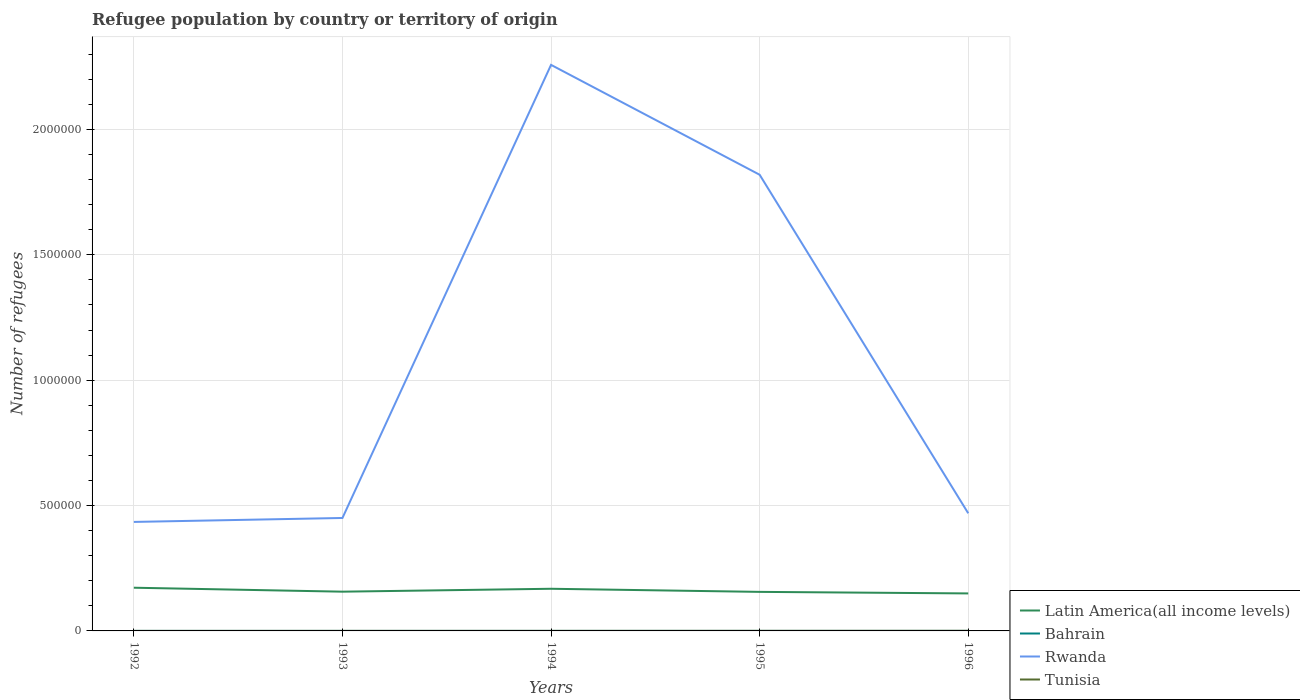Is the number of lines equal to the number of legend labels?
Provide a succinct answer. Yes. Across all years, what is the maximum number of refugees in Bahrain?
Your response must be concise. 53. What is the total number of refugees in Latin America(all income levels) in the graph?
Keep it short and to the point. 6175. What is the difference between the highest and the second highest number of refugees in Tunisia?
Make the answer very short. 320. Is the number of refugees in Latin America(all income levels) strictly greater than the number of refugees in Bahrain over the years?
Provide a succinct answer. No. How many lines are there?
Give a very brief answer. 4. How many years are there in the graph?
Offer a terse response. 5. Where does the legend appear in the graph?
Offer a terse response. Bottom right. How many legend labels are there?
Your answer should be compact. 4. What is the title of the graph?
Make the answer very short. Refugee population by country or territory of origin. What is the label or title of the Y-axis?
Your answer should be very brief. Number of refugees. What is the Number of refugees of Latin America(all income levels) in 1992?
Your response must be concise. 1.72e+05. What is the Number of refugees of Rwanda in 1992?
Your answer should be very brief. 4.35e+05. What is the Number of refugees of Latin America(all income levels) in 1993?
Give a very brief answer. 1.57e+05. What is the Number of refugees of Rwanda in 1993?
Keep it short and to the point. 4.50e+05. What is the Number of refugees in Tunisia in 1993?
Offer a terse response. 104. What is the Number of refugees of Latin America(all income levels) in 1994?
Offer a terse response. 1.68e+05. What is the Number of refugees of Bahrain in 1994?
Keep it short and to the point. 75. What is the Number of refugees of Rwanda in 1994?
Offer a very short reply. 2.26e+06. What is the Number of refugees of Tunisia in 1994?
Provide a short and direct response. 212. What is the Number of refugees of Latin America(all income levels) in 1995?
Give a very brief answer. 1.56e+05. What is the Number of refugees in Rwanda in 1995?
Keep it short and to the point. 1.82e+06. What is the Number of refugees in Tunisia in 1995?
Offer a very short reply. 333. What is the Number of refugees of Latin America(all income levels) in 1996?
Provide a succinct answer. 1.50e+05. What is the Number of refugees in Bahrain in 1996?
Give a very brief answer. 63. What is the Number of refugees in Rwanda in 1996?
Your response must be concise. 4.69e+05. What is the Number of refugees of Tunisia in 1996?
Your answer should be compact. 406. Across all years, what is the maximum Number of refugees in Latin America(all income levels)?
Ensure brevity in your answer.  1.72e+05. Across all years, what is the maximum Number of refugees in Rwanda?
Your answer should be very brief. 2.26e+06. Across all years, what is the maximum Number of refugees of Tunisia?
Offer a very short reply. 406. Across all years, what is the minimum Number of refugees in Latin America(all income levels)?
Offer a very short reply. 1.50e+05. Across all years, what is the minimum Number of refugees of Bahrain?
Make the answer very short. 53. Across all years, what is the minimum Number of refugees of Rwanda?
Make the answer very short. 4.35e+05. What is the total Number of refugees in Latin America(all income levels) in the graph?
Keep it short and to the point. 8.02e+05. What is the total Number of refugees of Bahrain in the graph?
Your answer should be very brief. 322. What is the total Number of refugees in Rwanda in the graph?
Offer a very short reply. 5.43e+06. What is the total Number of refugees in Tunisia in the graph?
Give a very brief answer. 1141. What is the difference between the Number of refugees in Latin America(all income levels) in 1992 and that in 1993?
Offer a terse response. 1.58e+04. What is the difference between the Number of refugees of Rwanda in 1992 and that in 1993?
Offer a terse response. -1.57e+04. What is the difference between the Number of refugees in Tunisia in 1992 and that in 1993?
Give a very brief answer. -18. What is the difference between the Number of refugees of Latin America(all income levels) in 1992 and that in 1994?
Offer a very short reply. 4203. What is the difference between the Number of refugees in Rwanda in 1992 and that in 1994?
Ensure brevity in your answer.  -1.82e+06. What is the difference between the Number of refugees of Tunisia in 1992 and that in 1994?
Your answer should be very brief. -126. What is the difference between the Number of refugees of Latin America(all income levels) in 1992 and that in 1995?
Your answer should be compact. 1.66e+04. What is the difference between the Number of refugees in Bahrain in 1992 and that in 1995?
Provide a succinct answer. -18. What is the difference between the Number of refugees in Rwanda in 1992 and that in 1995?
Offer a very short reply. -1.38e+06. What is the difference between the Number of refugees in Tunisia in 1992 and that in 1995?
Offer a terse response. -247. What is the difference between the Number of refugees in Latin America(all income levels) in 1992 and that in 1996?
Your answer should be compact. 2.28e+04. What is the difference between the Number of refugees of Bahrain in 1992 and that in 1996?
Your response must be concise. -10. What is the difference between the Number of refugees in Rwanda in 1992 and that in 1996?
Ensure brevity in your answer.  -3.44e+04. What is the difference between the Number of refugees of Tunisia in 1992 and that in 1996?
Your response must be concise. -320. What is the difference between the Number of refugees in Latin America(all income levels) in 1993 and that in 1994?
Your answer should be compact. -1.16e+04. What is the difference between the Number of refugees in Rwanda in 1993 and that in 1994?
Offer a terse response. -1.81e+06. What is the difference between the Number of refugees in Tunisia in 1993 and that in 1994?
Offer a terse response. -108. What is the difference between the Number of refugees in Latin America(all income levels) in 1993 and that in 1995?
Offer a terse response. 825. What is the difference between the Number of refugees in Bahrain in 1993 and that in 1995?
Provide a succinct answer. -11. What is the difference between the Number of refugees of Rwanda in 1993 and that in 1995?
Keep it short and to the point. -1.37e+06. What is the difference between the Number of refugees in Tunisia in 1993 and that in 1995?
Give a very brief answer. -229. What is the difference between the Number of refugees of Latin America(all income levels) in 1993 and that in 1996?
Ensure brevity in your answer.  7000. What is the difference between the Number of refugees in Bahrain in 1993 and that in 1996?
Make the answer very short. -3. What is the difference between the Number of refugees in Rwanda in 1993 and that in 1996?
Your answer should be compact. -1.87e+04. What is the difference between the Number of refugees of Tunisia in 1993 and that in 1996?
Your response must be concise. -302. What is the difference between the Number of refugees in Latin America(all income levels) in 1994 and that in 1995?
Provide a short and direct response. 1.24e+04. What is the difference between the Number of refugees of Bahrain in 1994 and that in 1995?
Give a very brief answer. 4. What is the difference between the Number of refugees in Rwanda in 1994 and that in 1995?
Your answer should be compact. 4.38e+05. What is the difference between the Number of refugees of Tunisia in 1994 and that in 1995?
Make the answer very short. -121. What is the difference between the Number of refugees in Latin America(all income levels) in 1994 and that in 1996?
Make the answer very short. 1.86e+04. What is the difference between the Number of refugees in Bahrain in 1994 and that in 1996?
Provide a short and direct response. 12. What is the difference between the Number of refugees in Rwanda in 1994 and that in 1996?
Make the answer very short. 1.79e+06. What is the difference between the Number of refugees of Tunisia in 1994 and that in 1996?
Provide a succinct answer. -194. What is the difference between the Number of refugees of Latin America(all income levels) in 1995 and that in 1996?
Your answer should be compact. 6175. What is the difference between the Number of refugees of Rwanda in 1995 and that in 1996?
Offer a terse response. 1.35e+06. What is the difference between the Number of refugees of Tunisia in 1995 and that in 1996?
Ensure brevity in your answer.  -73. What is the difference between the Number of refugees of Latin America(all income levels) in 1992 and the Number of refugees of Bahrain in 1993?
Offer a very short reply. 1.72e+05. What is the difference between the Number of refugees in Latin America(all income levels) in 1992 and the Number of refugees in Rwanda in 1993?
Keep it short and to the point. -2.78e+05. What is the difference between the Number of refugees of Latin America(all income levels) in 1992 and the Number of refugees of Tunisia in 1993?
Your response must be concise. 1.72e+05. What is the difference between the Number of refugees of Bahrain in 1992 and the Number of refugees of Rwanda in 1993?
Your answer should be very brief. -4.50e+05. What is the difference between the Number of refugees of Bahrain in 1992 and the Number of refugees of Tunisia in 1993?
Your answer should be compact. -51. What is the difference between the Number of refugees of Rwanda in 1992 and the Number of refugees of Tunisia in 1993?
Keep it short and to the point. 4.35e+05. What is the difference between the Number of refugees of Latin America(all income levels) in 1992 and the Number of refugees of Bahrain in 1994?
Your answer should be compact. 1.72e+05. What is the difference between the Number of refugees of Latin America(all income levels) in 1992 and the Number of refugees of Rwanda in 1994?
Give a very brief answer. -2.09e+06. What is the difference between the Number of refugees of Latin America(all income levels) in 1992 and the Number of refugees of Tunisia in 1994?
Your response must be concise. 1.72e+05. What is the difference between the Number of refugees in Bahrain in 1992 and the Number of refugees in Rwanda in 1994?
Your answer should be very brief. -2.26e+06. What is the difference between the Number of refugees of Bahrain in 1992 and the Number of refugees of Tunisia in 1994?
Keep it short and to the point. -159. What is the difference between the Number of refugees in Rwanda in 1992 and the Number of refugees in Tunisia in 1994?
Your response must be concise. 4.35e+05. What is the difference between the Number of refugees of Latin America(all income levels) in 1992 and the Number of refugees of Bahrain in 1995?
Your answer should be compact. 1.72e+05. What is the difference between the Number of refugees of Latin America(all income levels) in 1992 and the Number of refugees of Rwanda in 1995?
Give a very brief answer. -1.65e+06. What is the difference between the Number of refugees of Latin America(all income levels) in 1992 and the Number of refugees of Tunisia in 1995?
Ensure brevity in your answer.  1.72e+05. What is the difference between the Number of refugees of Bahrain in 1992 and the Number of refugees of Rwanda in 1995?
Your answer should be very brief. -1.82e+06. What is the difference between the Number of refugees of Bahrain in 1992 and the Number of refugees of Tunisia in 1995?
Give a very brief answer. -280. What is the difference between the Number of refugees of Rwanda in 1992 and the Number of refugees of Tunisia in 1995?
Keep it short and to the point. 4.34e+05. What is the difference between the Number of refugees of Latin America(all income levels) in 1992 and the Number of refugees of Bahrain in 1996?
Offer a terse response. 1.72e+05. What is the difference between the Number of refugees of Latin America(all income levels) in 1992 and the Number of refugees of Rwanda in 1996?
Provide a succinct answer. -2.97e+05. What is the difference between the Number of refugees in Latin America(all income levels) in 1992 and the Number of refugees in Tunisia in 1996?
Make the answer very short. 1.72e+05. What is the difference between the Number of refugees in Bahrain in 1992 and the Number of refugees in Rwanda in 1996?
Your response must be concise. -4.69e+05. What is the difference between the Number of refugees in Bahrain in 1992 and the Number of refugees in Tunisia in 1996?
Make the answer very short. -353. What is the difference between the Number of refugees of Rwanda in 1992 and the Number of refugees of Tunisia in 1996?
Your answer should be compact. 4.34e+05. What is the difference between the Number of refugees in Latin America(all income levels) in 1993 and the Number of refugees in Bahrain in 1994?
Keep it short and to the point. 1.56e+05. What is the difference between the Number of refugees in Latin America(all income levels) in 1993 and the Number of refugees in Rwanda in 1994?
Give a very brief answer. -2.10e+06. What is the difference between the Number of refugees in Latin America(all income levels) in 1993 and the Number of refugees in Tunisia in 1994?
Provide a succinct answer. 1.56e+05. What is the difference between the Number of refugees of Bahrain in 1993 and the Number of refugees of Rwanda in 1994?
Ensure brevity in your answer.  -2.26e+06. What is the difference between the Number of refugees in Bahrain in 1993 and the Number of refugees in Tunisia in 1994?
Keep it short and to the point. -152. What is the difference between the Number of refugees in Rwanda in 1993 and the Number of refugees in Tunisia in 1994?
Offer a terse response. 4.50e+05. What is the difference between the Number of refugees of Latin America(all income levels) in 1993 and the Number of refugees of Bahrain in 1995?
Provide a succinct answer. 1.56e+05. What is the difference between the Number of refugees of Latin America(all income levels) in 1993 and the Number of refugees of Rwanda in 1995?
Your answer should be compact. -1.66e+06. What is the difference between the Number of refugees of Latin America(all income levels) in 1993 and the Number of refugees of Tunisia in 1995?
Provide a short and direct response. 1.56e+05. What is the difference between the Number of refugees in Bahrain in 1993 and the Number of refugees in Rwanda in 1995?
Provide a succinct answer. -1.82e+06. What is the difference between the Number of refugees of Bahrain in 1993 and the Number of refugees of Tunisia in 1995?
Make the answer very short. -273. What is the difference between the Number of refugees of Rwanda in 1993 and the Number of refugees of Tunisia in 1995?
Your response must be concise. 4.50e+05. What is the difference between the Number of refugees of Latin America(all income levels) in 1993 and the Number of refugees of Bahrain in 1996?
Make the answer very short. 1.56e+05. What is the difference between the Number of refugees in Latin America(all income levels) in 1993 and the Number of refugees in Rwanda in 1996?
Provide a short and direct response. -3.13e+05. What is the difference between the Number of refugees in Latin America(all income levels) in 1993 and the Number of refugees in Tunisia in 1996?
Ensure brevity in your answer.  1.56e+05. What is the difference between the Number of refugees in Bahrain in 1993 and the Number of refugees in Rwanda in 1996?
Give a very brief answer. -4.69e+05. What is the difference between the Number of refugees of Bahrain in 1993 and the Number of refugees of Tunisia in 1996?
Provide a short and direct response. -346. What is the difference between the Number of refugees of Rwanda in 1993 and the Number of refugees of Tunisia in 1996?
Make the answer very short. 4.50e+05. What is the difference between the Number of refugees of Latin America(all income levels) in 1994 and the Number of refugees of Bahrain in 1995?
Provide a succinct answer. 1.68e+05. What is the difference between the Number of refugees in Latin America(all income levels) in 1994 and the Number of refugees in Rwanda in 1995?
Your response must be concise. -1.65e+06. What is the difference between the Number of refugees of Latin America(all income levels) in 1994 and the Number of refugees of Tunisia in 1995?
Provide a short and direct response. 1.68e+05. What is the difference between the Number of refugees of Bahrain in 1994 and the Number of refugees of Rwanda in 1995?
Give a very brief answer. -1.82e+06. What is the difference between the Number of refugees of Bahrain in 1994 and the Number of refugees of Tunisia in 1995?
Keep it short and to the point. -258. What is the difference between the Number of refugees in Rwanda in 1994 and the Number of refugees in Tunisia in 1995?
Provide a succinct answer. 2.26e+06. What is the difference between the Number of refugees of Latin America(all income levels) in 1994 and the Number of refugees of Bahrain in 1996?
Keep it short and to the point. 1.68e+05. What is the difference between the Number of refugees in Latin America(all income levels) in 1994 and the Number of refugees in Rwanda in 1996?
Keep it short and to the point. -3.01e+05. What is the difference between the Number of refugees in Latin America(all income levels) in 1994 and the Number of refugees in Tunisia in 1996?
Provide a short and direct response. 1.68e+05. What is the difference between the Number of refugees in Bahrain in 1994 and the Number of refugees in Rwanda in 1996?
Give a very brief answer. -4.69e+05. What is the difference between the Number of refugees of Bahrain in 1994 and the Number of refugees of Tunisia in 1996?
Provide a short and direct response. -331. What is the difference between the Number of refugees in Rwanda in 1994 and the Number of refugees in Tunisia in 1996?
Keep it short and to the point. 2.26e+06. What is the difference between the Number of refugees in Latin America(all income levels) in 1995 and the Number of refugees in Bahrain in 1996?
Give a very brief answer. 1.56e+05. What is the difference between the Number of refugees of Latin America(all income levels) in 1995 and the Number of refugees of Rwanda in 1996?
Your answer should be very brief. -3.13e+05. What is the difference between the Number of refugees in Latin America(all income levels) in 1995 and the Number of refugees in Tunisia in 1996?
Make the answer very short. 1.55e+05. What is the difference between the Number of refugees in Bahrain in 1995 and the Number of refugees in Rwanda in 1996?
Offer a very short reply. -4.69e+05. What is the difference between the Number of refugees in Bahrain in 1995 and the Number of refugees in Tunisia in 1996?
Your response must be concise. -335. What is the difference between the Number of refugees of Rwanda in 1995 and the Number of refugees of Tunisia in 1996?
Make the answer very short. 1.82e+06. What is the average Number of refugees in Latin America(all income levels) per year?
Give a very brief answer. 1.60e+05. What is the average Number of refugees in Bahrain per year?
Your response must be concise. 64.4. What is the average Number of refugees in Rwanda per year?
Provide a succinct answer. 1.09e+06. What is the average Number of refugees of Tunisia per year?
Keep it short and to the point. 228.2. In the year 1992, what is the difference between the Number of refugees in Latin America(all income levels) and Number of refugees in Bahrain?
Make the answer very short. 1.72e+05. In the year 1992, what is the difference between the Number of refugees in Latin America(all income levels) and Number of refugees in Rwanda?
Offer a very short reply. -2.62e+05. In the year 1992, what is the difference between the Number of refugees in Latin America(all income levels) and Number of refugees in Tunisia?
Your response must be concise. 1.72e+05. In the year 1992, what is the difference between the Number of refugees of Bahrain and Number of refugees of Rwanda?
Your response must be concise. -4.35e+05. In the year 1992, what is the difference between the Number of refugees in Bahrain and Number of refugees in Tunisia?
Make the answer very short. -33. In the year 1992, what is the difference between the Number of refugees of Rwanda and Number of refugees of Tunisia?
Your answer should be very brief. 4.35e+05. In the year 1993, what is the difference between the Number of refugees of Latin America(all income levels) and Number of refugees of Bahrain?
Give a very brief answer. 1.56e+05. In the year 1993, what is the difference between the Number of refugees in Latin America(all income levels) and Number of refugees in Rwanda?
Your response must be concise. -2.94e+05. In the year 1993, what is the difference between the Number of refugees in Latin America(all income levels) and Number of refugees in Tunisia?
Ensure brevity in your answer.  1.56e+05. In the year 1993, what is the difference between the Number of refugees of Bahrain and Number of refugees of Rwanda?
Provide a succinct answer. -4.50e+05. In the year 1993, what is the difference between the Number of refugees in Bahrain and Number of refugees in Tunisia?
Make the answer very short. -44. In the year 1993, what is the difference between the Number of refugees in Rwanda and Number of refugees in Tunisia?
Keep it short and to the point. 4.50e+05. In the year 1994, what is the difference between the Number of refugees of Latin America(all income levels) and Number of refugees of Bahrain?
Make the answer very short. 1.68e+05. In the year 1994, what is the difference between the Number of refugees of Latin America(all income levels) and Number of refugees of Rwanda?
Make the answer very short. -2.09e+06. In the year 1994, what is the difference between the Number of refugees in Latin America(all income levels) and Number of refugees in Tunisia?
Offer a very short reply. 1.68e+05. In the year 1994, what is the difference between the Number of refugees in Bahrain and Number of refugees in Rwanda?
Your answer should be very brief. -2.26e+06. In the year 1994, what is the difference between the Number of refugees of Bahrain and Number of refugees of Tunisia?
Provide a short and direct response. -137. In the year 1994, what is the difference between the Number of refugees in Rwanda and Number of refugees in Tunisia?
Provide a succinct answer. 2.26e+06. In the year 1995, what is the difference between the Number of refugees of Latin America(all income levels) and Number of refugees of Bahrain?
Offer a terse response. 1.56e+05. In the year 1995, what is the difference between the Number of refugees of Latin America(all income levels) and Number of refugees of Rwanda?
Your response must be concise. -1.66e+06. In the year 1995, what is the difference between the Number of refugees in Latin America(all income levels) and Number of refugees in Tunisia?
Keep it short and to the point. 1.55e+05. In the year 1995, what is the difference between the Number of refugees of Bahrain and Number of refugees of Rwanda?
Offer a terse response. -1.82e+06. In the year 1995, what is the difference between the Number of refugees of Bahrain and Number of refugees of Tunisia?
Ensure brevity in your answer.  -262. In the year 1995, what is the difference between the Number of refugees of Rwanda and Number of refugees of Tunisia?
Ensure brevity in your answer.  1.82e+06. In the year 1996, what is the difference between the Number of refugees in Latin America(all income levels) and Number of refugees in Bahrain?
Give a very brief answer. 1.49e+05. In the year 1996, what is the difference between the Number of refugees of Latin America(all income levels) and Number of refugees of Rwanda?
Your answer should be compact. -3.20e+05. In the year 1996, what is the difference between the Number of refugees of Latin America(all income levels) and Number of refugees of Tunisia?
Provide a succinct answer. 1.49e+05. In the year 1996, what is the difference between the Number of refugees in Bahrain and Number of refugees in Rwanda?
Offer a terse response. -4.69e+05. In the year 1996, what is the difference between the Number of refugees in Bahrain and Number of refugees in Tunisia?
Offer a terse response. -343. In the year 1996, what is the difference between the Number of refugees in Rwanda and Number of refugees in Tunisia?
Keep it short and to the point. 4.69e+05. What is the ratio of the Number of refugees of Latin America(all income levels) in 1992 to that in 1993?
Ensure brevity in your answer.  1.1. What is the ratio of the Number of refugees of Bahrain in 1992 to that in 1993?
Keep it short and to the point. 0.88. What is the ratio of the Number of refugees of Rwanda in 1992 to that in 1993?
Offer a terse response. 0.97. What is the ratio of the Number of refugees of Tunisia in 1992 to that in 1993?
Keep it short and to the point. 0.83. What is the ratio of the Number of refugees of Latin America(all income levels) in 1992 to that in 1994?
Offer a terse response. 1.02. What is the ratio of the Number of refugees in Bahrain in 1992 to that in 1994?
Give a very brief answer. 0.71. What is the ratio of the Number of refugees in Rwanda in 1992 to that in 1994?
Provide a short and direct response. 0.19. What is the ratio of the Number of refugees of Tunisia in 1992 to that in 1994?
Make the answer very short. 0.41. What is the ratio of the Number of refugees of Latin America(all income levels) in 1992 to that in 1995?
Your answer should be very brief. 1.11. What is the ratio of the Number of refugees in Bahrain in 1992 to that in 1995?
Provide a short and direct response. 0.75. What is the ratio of the Number of refugees of Rwanda in 1992 to that in 1995?
Keep it short and to the point. 0.24. What is the ratio of the Number of refugees in Tunisia in 1992 to that in 1995?
Your response must be concise. 0.26. What is the ratio of the Number of refugees of Latin America(all income levels) in 1992 to that in 1996?
Keep it short and to the point. 1.15. What is the ratio of the Number of refugees in Bahrain in 1992 to that in 1996?
Offer a very short reply. 0.84. What is the ratio of the Number of refugees in Rwanda in 1992 to that in 1996?
Provide a short and direct response. 0.93. What is the ratio of the Number of refugees in Tunisia in 1992 to that in 1996?
Offer a very short reply. 0.21. What is the ratio of the Number of refugees in Latin America(all income levels) in 1993 to that in 1994?
Your response must be concise. 0.93. What is the ratio of the Number of refugees in Rwanda in 1993 to that in 1994?
Your answer should be very brief. 0.2. What is the ratio of the Number of refugees of Tunisia in 1993 to that in 1994?
Offer a very short reply. 0.49. What is the ratio of the Number of refugees of Latin America(all income levels) in 1993 to that in 1995?
Keep it short and to the point. 1.01. What is the ratio of the Number of refugees of Bahrain in 1993 to that in 1995?
Your answer should be very brief. 0.85. What is the ratio of the Number of refugees of Rwanda in 1993 to that in 1995?
Your response must be concise. 0.25. What is the ratio of the Number of refugees in Tunisia in 1993 to that in 1995?
Your response must be concise. 0.31. What is the ratio of the Number of refugees in Latin America(all income levels) in 1993 to that in 1996?
Ensure brevity in your answer.  1.05. What is the ratio of the Number of refugees of Rwanda in 1993 to that in 1996?
Your answer should be compact. 0.96. What is the ratio of the Number of refugees in Tunisia in 1993 to that in 1996?
Keep it short and to the point. 0.26. What is the ratio of the Number of refugees of Latin America(all income levels) in 1994 to that in 1995?
Make the answer very short. 1.08. What is the ratio of the Number of refugees of Bahrain in 1994 to that in 1995?
Offer a terse response. 1.06. What is the ratio of the Number of refugees in Rwanda in 1994 to that in 1995?
Your answer should be very brief. 1.24. What is the ratio of the Number of refugees of Tunisia in 1994 to that in 1995?
Keep it short and to the point. 0.64. What is the ratio of the Number of refugees of Latin America(all income levels) in 1994 to that in 1996?
Provide a short and direct response. 1.12. What is the ratio of the Number of refugees in Bahrain in 1994 to that in 1996?
Provide a succinct answer. 1.19. What is the ratio of the Number of refugees of Rwanda in 1994 to that in 1996?
Provide a short and direct response. 4.81. What is the ratio of the Number of refugees of Tunisia in 1994 to that in 1996?
Offer a terse response. 0.52. What is the ratio of the Number of refugees of Latin America(all income levels) in 1995 to that in 1996?
Make the answer very short. 1.04. What is the ratio of the Number of refugees of Bahrain in 1995 to that in 1996?
Offer a terse response. 1.13. What is the ratio of the Number of refugees of Rwanda in 1995 to that in 1996?
Your response must be concise. 3.88. What is the ratio of the Number of refugees in Tunisia in 1995 to that in 1996?
Your answer should be very brief. 0.82. What is the difference between the highest and the second highest Number of refugees in Latin America(all income levels)?
Ensure brevity in your answer.  4203. What is the difference between the highest and the second highest Number of refugees in Rwanda?
Your answer should be compact. 4.38e+05. What is the difference between the highest and the lowest Number of refugees in Latin America(all income levels)?
Make the answer very short. 2.28e+04. What is the difference between the highest and the lowest Number of refugees of Bahrain?
Offer a terse response. 22. What is the difference between the highest and the lowest Number of refugees of Rwanda?
Your answer should be compact. 1.82e+06. What is the difference between the highest and the lowest Number of refugees in Tunisia?
Keep it short and to the point. 320. 